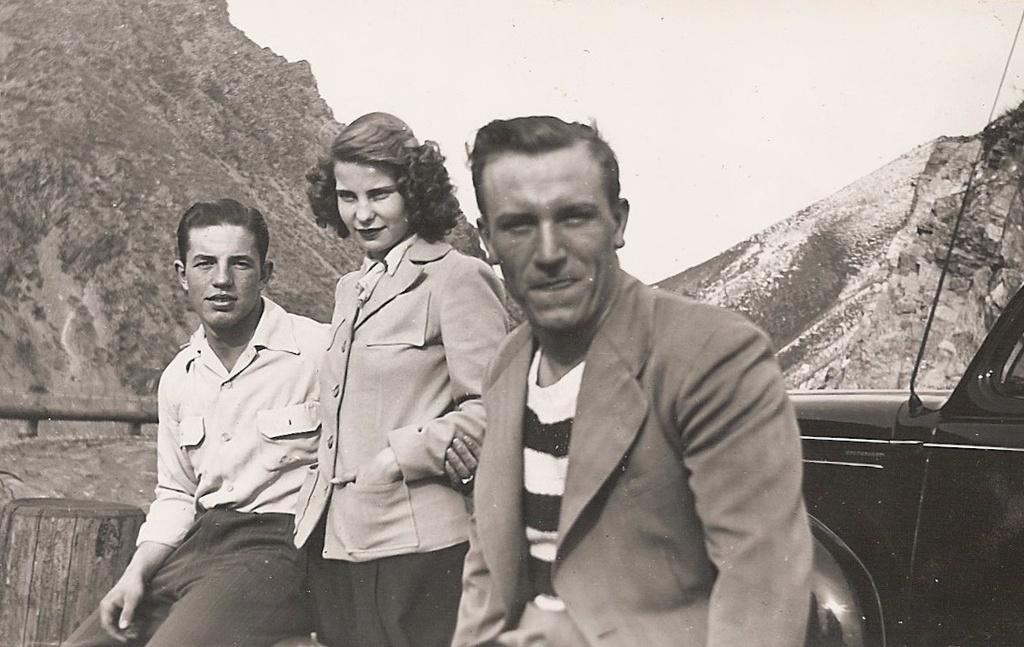Can you describe this image briefly? This is a black and white picture. In the background we can see the hills. In this picture we can see the woman and the men. They all are smiling. On the right side of the picture we can see a vehicle. On the left side of the picture it seems like a wooden object and the fence. 